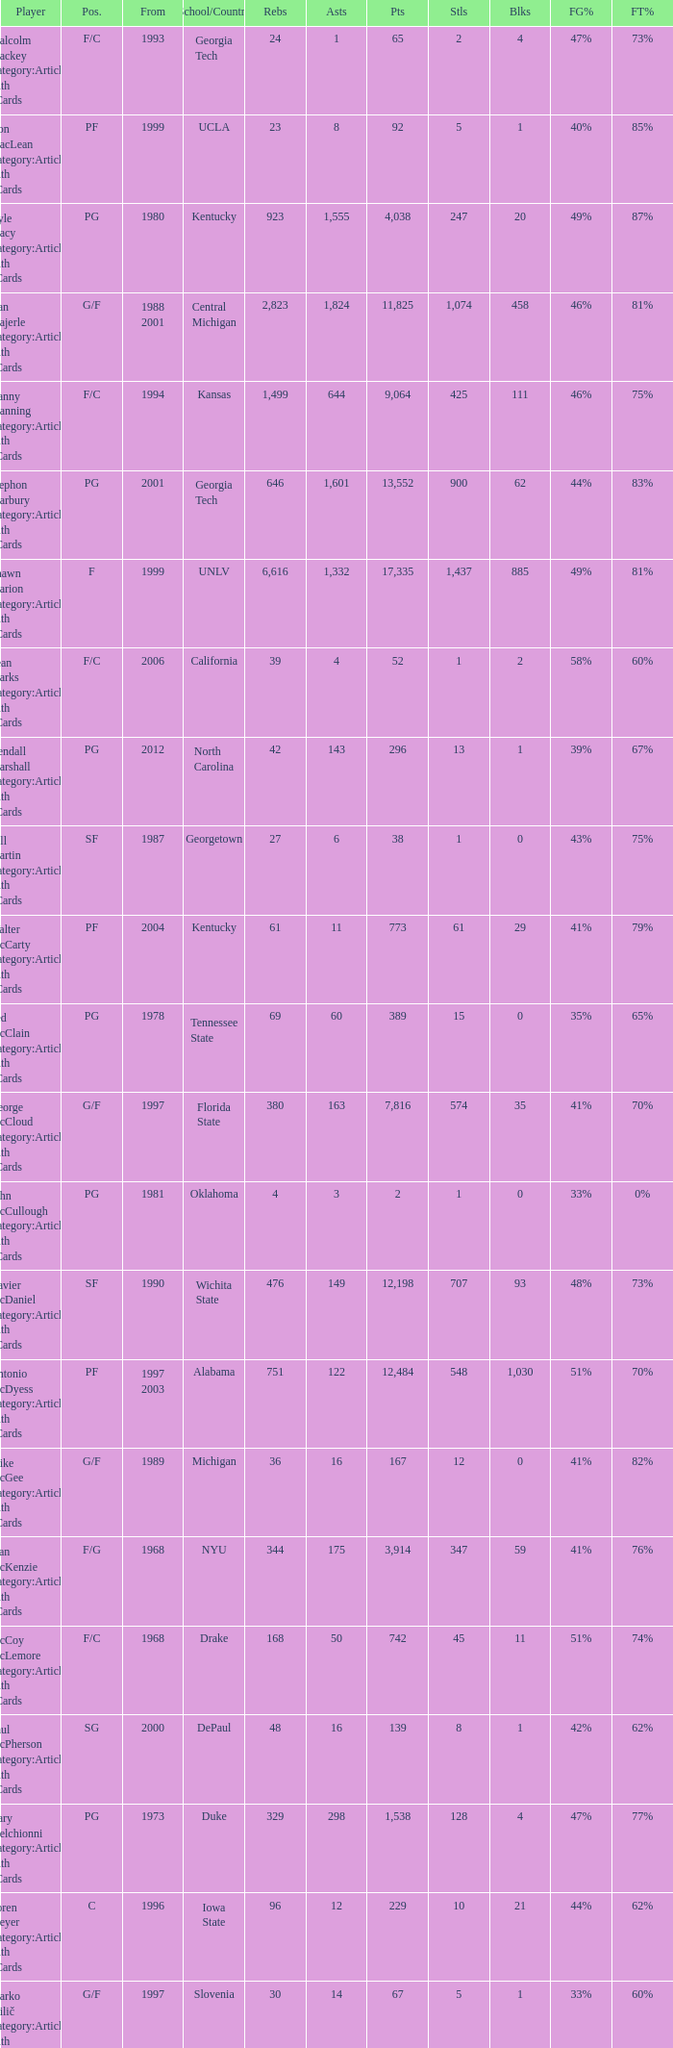What position does the player from arkansas play? C. 